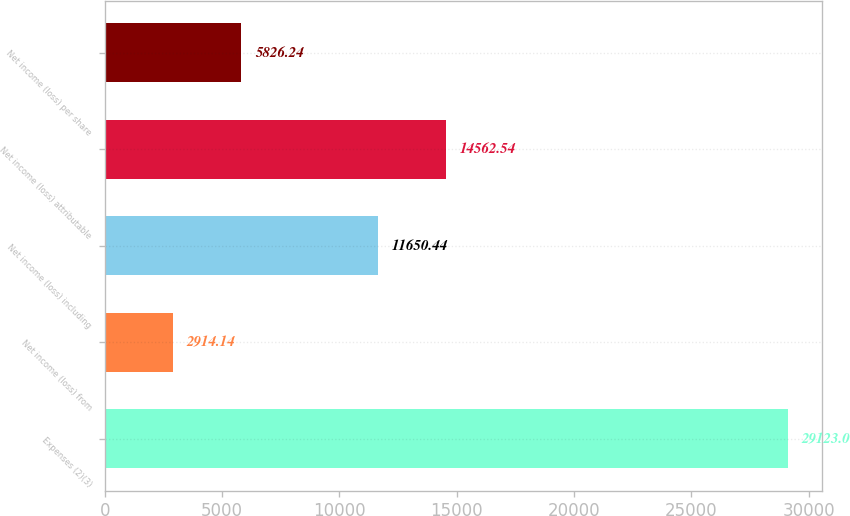<chart> <loc_0><loc_0><loc_500><loc_500><bar_chart><fcel>Expenses (2)(3)<fcel>Net income (loss) from<fcel>Net income (loss) including<fcel>Net income (loss) attributable<fcel>Net income (loss) per share<nl><fcel>29123<fcel>2914.14<fcel>11650.4<fcel>14562.5<fcel>5826.24<nl></chart> 